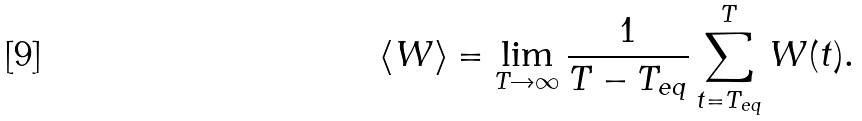Convert formula to latex. <formula><loc_0><loc_0><loc_500><loc_500>\langle W \rangle = \lim _ { T \rightarrow \infty } \frac { 1 } { T - T _ { e q } } \sum _ { t = T _ { e q } } ^ { T } W ( t ) .</formula> 